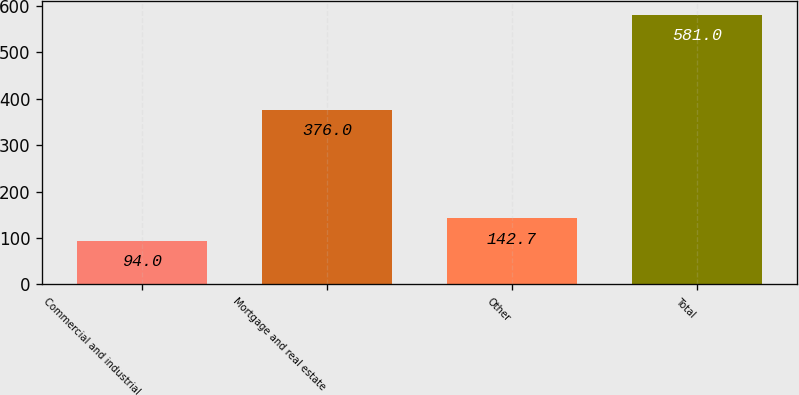<chart> <loc_0><loc_0><loc_500><loc_500><bar_chart><fcel>Commercial and industrial<fcel>Mortgage and real estate<fcel>Other<fcel>Total<nl><fcel>94<fcel>376<fcel>142.7<fcel>581<nl></chart> 